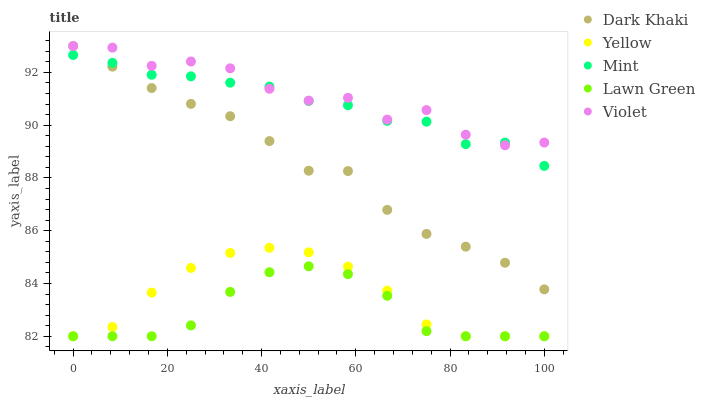Does Lawn Green have the minimum area under the curve?
Answer yes or no. Yes. Does Violet have the maximum area under the curve?
Answer yes or no. Yes. Does Mint have the minimum area under the curve?
Answer yes or no. No. Does Mint have the maximum area under the curve?
Answer yes or no. No. Is Yellow the smoothest?
Answer yes or no. Yes. Is Violet the roughest?
Answer yes or no. Yes. Is Lawn Green the smoothest?
Answer yes or no. No. Is Lawn Green the roughest?
Answer yes or no. No. Does Lawn Green have the lowest value?
Answer yes or no. Yes. Does Mint have the lowest value?
Answer yes or no. No. Does Violet have the highest value?
Answer yes or no. Yes. Does Mint have the highest value?
Answer yes or no. No. Is Lawn Green less than Dark Khaki?
Answer yes or no. Yes. Is Mint greater than Yellow?
Answer yes or no. Yes. Does Violet intersect Dark Khaki?
Answer yes or no. Yes. Is Violet less than Dark Khaki?
Answer yes or no. No. Is Violet greater than Dark Khaki?
Answer yes or no. No. Does Lawn Green intersect Dark Khaki?
Answer yes or no. No. 